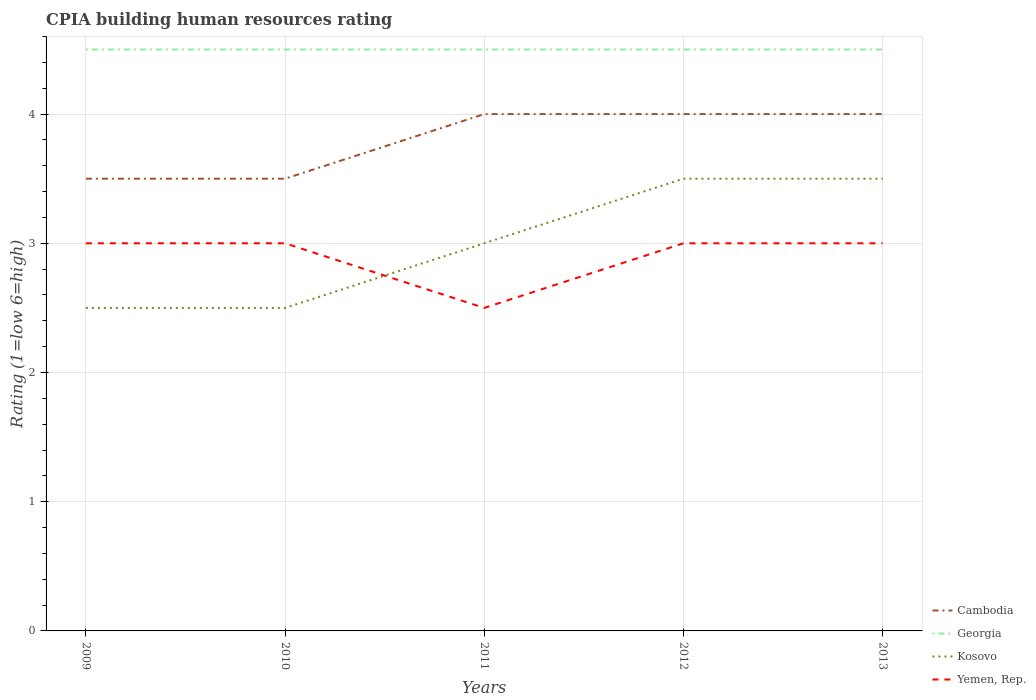Does the line corresponding to Cambodia intersect with the line corresponding to Georgia?
Make the answer very short. No. Is the number of lines equal to the number of legend labels?
Keep it short and to the point. Yes. In which year was the CPIA rating in Kosovo maximum?
Give a very brief answer. 2009. What is the difference between the highest and the second highest CPIA rating in Georgia?
Provide a succinct answer. 0. What is the difference between the highest and the lowest CPIA rating in Georgia?
Offer a very short reply. 0. Where does the legend appear in the graph?
Give a very brief answer. Bottom right. How many legend labels are there?
Your answer should be very brief. 4. How are the legend labels stacked?
Your answer should be very brief. Vertical. What is the title of the graph?
Your answer should be very brief. CPIA building human resources rating. Does "Belize" appear as one of the legend labels in the graph?
Your answer should be very brief. No. What is the Rating (1=low 6=high) in Cambodia in 2009?
Provide a succinct answer. 3.5. What is the Rating (1=low 6=high) of Kosovo in 2009?
Provide a succinct answer. 2.5. What is the Rating (1=low 6=high) in Yemen, Rep. in 2009?
Give a very brief answer. 3. What is the Rating (1=low 6=high) in Cambodia in 2010?
Keep it short and to the point. 3.5. What is the Rating (1=low 6=high) of Yemen, Rep. in 2010?
Your answer should be compact. 3. What is the Rating (1=low 6=high) of Georgia in 2011?
Offer a terse response. 4.5. What is the Rating (1=low 6=high) of Kosovo in 2012?
Your answer should be very brief. 3.5. What is the Rating (1=low 6=high) in Yemen, Rep. in 2012?
Offer a terse response. 3. What is the Rating (1=low 6=high) of Kosovo in 2013?
Make the answer very short. 3.5. Across all years, what is the minimum Rating (1=low 6=high) of Cambodia?
Make the answer very short. 3.5. Across all years, what is the minimum Rating (1=low 6=high) of Georgia?
Make the answer very short. 4.5. Across all years, what is the minimum Rating (1=low 6=high) of Yemen, Rep.?
Your answer should be compact. 2.5. What is the total Rating (1=low 6=high) in Cambodia in the graph?
Your answer should be compact. 19. What is the difference between the Rating (1=low 6=high) of Georgia in 2009 and that in 2010?
Your answer should be very brief. 0. What is the difference between the Rating (1=low 6=high) in Kosovo in 2009 and that in 2010?
Your response must be concise. 0. What is the difference between the Rating (1=low 6=high) of Cambodia in 2009 and that in 2011?
Your answer should be compact. -0.5. What is the difference between the Rating (1=low 6=high) of Georgia in 2009 and that in 2011?
Offer a very short reply. 0. What is the difference between the Rating (1=low 6=high) in Yemen, Rep. in 2009 and that in 2011?
Your answer should be compact. 0.5. What is the difference between the Rating (1=low 6=high) in Cambodia in 2009 and that in 2012?
Offer a very short reply. -0.5. What is the difference between the Rating (1=low 6=high) of Georgia in 2009 and that in 2012?
Offer a very short reply. 0. What is the difference between the Rating (1=low 6=high) of Yemen, Rep. in 2009 and that in 2013?
Provide a short and direct response. 0. What is the difference between the Rating (1=low 6=high) in Cambodia in 2010 and that in 2011?
Ensure brevity in your answer.  -0.5. What is the difference between the Rating (1=low 6=high) in Kosovo in 2010 and that in 2012?
Ensure brevity in your answer.  -1. What is the difference between the Rating (1=low 6=high) in Cambodia in 2010 and that in 2013?
Offer a terse response. -0.5. What is the difference between the Rating (1=low 6=high) in Georgia in 2010 and that in 2013?
Offer a very short reply. 0. What is the difference between the Rating (1=low 6=high) of Georgia in 2011 and that in 2012?
Ensure brevity in your answer.  0. What is the difference between the Rating (1=low 6=high) of Kosovo in 2011 and that in 2012?
Your response must be concise. -0.5. What is the difference between the Rating (1=low 6=high) in Yemen, Rep. in 2011 and that in 2012?
Keep it short and to the point. -0.5. What is the difference between the Rating (1=low 6=high) of Cambodia in 2012 and that in 2013?
Provide a short and direct response. 0. What is the difference between the Rating (1=low 6=high) of Georgia in 2012 and that in 2013?
Ensure brevity in your answer.  0. What is the difference between the Rating (1=low 6=high) of Yemen, Rep. in 2012 and that in 2013?
Keep it short and to the point. 0. What is the difference between the Rating (1=low 6=high) of Cambodia in 2009 and the Rating (1=low 6=high) of Yemen, Rep. in 2010?
Ensure brevity in your answer.  0.5. What is the difference between the Rating (1=low 6=high) of Georgia in 2009 and the Rating (1=low 6=high) of Kosovo in 2010?
Make the answer very short. 2. What is the difference between the Rating (1=low 6=high) in Georgia in 2009 and the Rating (1=low 6=high) in Yemen, Rep. in 2010?
Offer a terse response. 1.5. What is the difference between the Rating (1=low 6=high) of Kosovo in 2009 and the Rating (1=low 6=high) of Yemen, Rep. in 2010?
Keep it short and to the point. -0.5. What is the difference between the Rating (1=low 6=high) in Cambodia in 2009 and the Rating (1=low 6=high) in Georgia in 2011?
Provide a succinct answer. -1. What is the difference between the Rating (1=low 6=high) of Georgia in 2009 and the Rating (1=low 6=high) of Kosovo in 2011?
Ensure brevity in your answer.  1.5. What is the difference between the Rating (1=low 6=high) in Georgia in 2009 and the Rating (1=low 6=high) in Yemen, Rep. in 2011?
Your answer should be compact. 2. What is the difference between the Rating (1=low 6=high) of Cambodia in 2009 and the Rating (1=low 6=high) of Georgia in 2012?
Provide a short and direct response. -1. What is the difference between the Rating (1=low 6=high) in Cambodia in 2009 and the Rating (1=low 6=high) in Yemen, Rep. in 2012?
Keep it short and to the point. 0.5. What is the difference between the Rating (1=low 6=high) in Georgia in 2009 and the Rating (1=low 6=high) in Kosovo in 2012?
Your answer should be compact. 1. What is the difference between the Rating (1=low 6=high) of Georgia in 2009 and the Rating (1=low 6=high) of Yemen, Rep. in 2012?
Make the answer very short. 1.5. What is the difference between the Rating (1=low 6=high) in Kosovo in 2009 and the Rating (1=low 6=high) in Yemen, Rep. in 2012?
Ensure brevity in your answer.  -0.5. What is the difference between the Rating (1=low 6=high) of Cambodia in 2009 and the Rating (1=low 6=high) of Yemen, Rep. in 2013?
Provide a short and direct response. 0.5. What is the difference between the Rating (1=low 6=high) in Georgia in 2009 and the Rating (1=low 6=high) in Kosovo in 2013?
Offer a very short reply. 1. What is the difference between the Rating (1=low 6=high) of Cambodia in 2010 and the Rating (1=low 6=high) of Georgia in 2011?
Provide a succinct answer. -1. What is the difference between the Rating (1=low 6=high) of Cambodia in 2010 and the Rating (1=low 6=high) of Kosovo in 2011?
Your answer should be very brief. 0.5. What is the difference between the Rating (1=low 6=high) of Cambodia in 2010 and the Rating (1=low 6=high) of Yemen, Rep. in 2011?
Your answer should be compact. 1. What is the difference between the Rating (1=low 6=high) of Cambodia in 2010 and the Rating (1=low 6=high) of Kosovo in 2012?
Provide a succinct answer. 0. What is the difference between the Rating (1=low 6=high) of Cambodia in 2010 and the Rating (1=low 6=high) of Yemen, Rep. in 2013?
Offer a terse response. 0.5. What is the difference between the Rating (1=low 6=high) in Georgia in 2010 and the Rating (1=low 6=high) in Kosovo in 2013?
Provide a succinct answer. 1. What is the difference between the Rating (1=low 6=high) in Georgia in 2010 and the Rating (1=low 6=high) in Yemen, Rep. in 2013?
Your answer should be very brief. 1.5. What is the difference between the Rating (1=low 6=high) in Cambodia in 2011 and the Rating (1=low 6=high) in Kosovo in 2012?
Your response must be concise. 0.5. What is the difference between the Rating (1=low 6=high) of Cambodia in 2011 and the Rating (1=low 6=high) of Yemen, Rep. in 2012?
Your response must be concise. 1. What is the difference between the Rating (1=low 6=high) in Georgia in 2011 and the Rating (1=low 6=high) in Kosovo in 2012?
Give a very brief answer. 1. What is the difference between the Rating (1=low 6=high) of Georgia in 2011 and the Rating (1=low 6=high) of Yemen, Rep. in 2012?
Your response must be concise. 1.5. What is the difference between the Rating (1=low 6=high) in Cambodia in 2011 and the Rating (1=low 6=high) in Georgia in 2013?
Offer a very short reply. -0.5. What is the difference between the Rating (1=low 6=high) of Cambodia in 2011 and the Rating (1=low 6=high) of Kosovo in 2013?
Provide a short and direct response. 0.5. What is the difference between the Rating (1=low 6=high) of Cambodia in 2011 and the Rating (1=low 6=high) of Yemen, Rep. in 2013?
Your response must be concise. 1. What is the difference between the Rating (1=low 6=high) of Georgia in 2011 and the Rating (1=low 6=high) of Kosovo in 2013?
Your answer should be very brief. 1. What is the difference between the Rating (1=low 6=high) of Georgia in 2011 and the Rating (1=low 6=high) of Yemen, Rep. in 2013?
Ensure brevity in your answer.  1.5. What is the difference between the Rating (1=low 6=high) of Cambodia in 2012 and the Rating (1=low 6=high) of Yemen, Rep. in 2013?
Give a very brief answer. 1. What is the difference between the Rating (1=low 6=high) of Georgia in 2012 and the Rating (1=low 6=high) of Yemen, Rep. in 2013?
Your answer should be compact. 1.5. What is the average Rating (1=low 6=high) in Georgia per year?
Your answer should be very brief. 4.5. What is the average Rating (1=low 6=high) of Yemen, Rep. per year?
Provide a succinct answer. 2.9. In the year 2009, what is the difference between the Rating (1=low 6=high) in Cambodia and Rating (1=low 6=high) in Kosovo?
Ensure brevity in your answer.  1. In the year 2009, what is the difference between the Rating (1=low 6=high) in Georgia and Rating (1=low 6=high) in Kosovo?
Ensure brevity in your answer.  2. In the year 2009, what is the difference between the Rating (1=low 6=high) in Georgia and Rating (1=low 6=high) in Yemen, Rep.?
Provide a short and direct response. 1.5. In the year 2010, what is the difference between the Rating (1=low 6=high) of Cambodia and Rating (1=low 6=high) of Georgia?
Provide a succinct answer. -1. In the year 2010, what is the difference between the Rating (1=low 6=high) of Cambodia and Rating (1=low 6=high) of Kosovo?
Make the answer very short. 1. In the year 2010, what is the difference between the Rating (1=low 6=high) of Georgia and Rating (1=low 6=high) of Kosovo?
Provide a short and direct response. 2. In the year 2010, what is the difference between the Rating (1=low 6=high) in Kosovo and Rating (1=low 6=high) in Yemen, Rep.?
Offer a very short reply. -0.5. In the year 2011, what is the difference between the Rating (1=low 6=high) in Cambodia and Rating (1=low 6=high) in Georgia?
Offer a terse response. -0.5. In the year 2011, what is the difference between the Rating (1=low 6=high) of Cambodia and Rating (1=low 6=high) of Kosovo?
Keep it short and to the point. 1. In the year 2011, what is the difference between the Rating (1=low 6=high) of Cambodia and Rating (1=low 6=high) of Yemen, Rep.?
Offer a very short reply. 1.5. In the year 2011, what is the difference between the Rating (1=low 6=high) in Georgia and Rating (1=low 6=high) in Kosovo?
Give a very brief answer. 1.5. In the year 2011, what is the difference between the Rating (1=low 6=high) in Georgia and Rating (1=low 6=high) in Yemen, Rep.?
Provide a short and direct response. 2. In the year 2011, what is the difference between the Rating (1=low 6=high) of Kosovo and Rating (1=low 6=high) of Yemen, Rep.?
Keep it short and to the point. 0.5. In the year 2012, what is the difference between the Rating (1=low 6=high) in Cambodia and Rating (1=low 6=high) in Georgia?
Your answer should be compact. -0.5. In the year 2012, what is the difference between the Rating (1=low 6=high) of Cambodia and Rating (1=low 6=high) of Kosovo?
Your answer should be compact. 0.5. In the year 2013, what is the difference between the Rating (1=low 6=high) of Georgia and Rating (1=low 6=high) of Kosovo?
Provide a short and direct response. 1. In the year 2013, what is the difference between the Rating (1=low 6=high) of Georgia and Rating (1=low 6=high) of Yemen, Rep.?
Your response must be concise. 1.5. In the year 2013, what is the difference between the Rating (1=low 6=high) of Kosovo and Rating (1=low 6=high) of Yemen, Rep.?
Provide a short and direct response. 0.5. What is the ratio of the Rating (1=low 6=high) in Georgia in 2009 to that in 2010?
Your response must be concise. 1. What is the ratio of the Rating (1=low 6=high) of Kosovo in 2009 to that in 2010?
Make the answer very short. 1. What is the ratio of the Rating (1=low 6=high) of Cambodia in 2009 to that in 2011?
Provide a succinct answer. 0.88. What is the ratio of the Rating (1=low 6=high) in Yemen, Rep. in 2009 to that in 2011?
Your answer should be compact. 1.2. What is the ratio of the Rating (1=low 6=high) of Kosovo in 2009 to that in 2012?
Your answer should be very brief. 0.71. What is the ratio of the Rating (1=low 6=high) in Yemen, Rep. in 2009 to that in 2012?
Keep it short and to the point. 1. What is the ratio of the Rating (1=low 6=high) of Cambodia in 2010 to that in 2011?
Provide a succinct answer. 0.88. What is the ratio of the Rating (1=low 6=high) of Kosovo in 2010 to that in 2011?
Provide a succinct answer. 0.83. What is the ratio of the Rating (1=low 6=high) in Kosovo in 2010 to that in 2012?
Make the answer very short. 0.71. What is the ratio of the Rating (1=low 6=high) in Cambodia in 2010 to that in 2013?
Offer a very short reply. 0.88. What is the ratio of the Rating (1=low 6=high) in Georgia in 2010 to that in 2013?
Keep it short and to the point. 1. What is the ratio of the Rating (1=low 6=high) of Yemen, Rep. in 2010 to that in 2013?
Make the answer very short. 1. What is the ratio of the Rating (1=low 6=high) of Georgia in 2011 to that in 2012?
Make the answer very short. 1. What is the ratio of the Rating (1=low 6=high) of Yemen, Rep. in 2011 to that in 2012?
Give a very brief answer. 0.83. What is the ratio of the Rating (1=low 6=high) of Cambodia in 2011 to that in 2013?
Your answer should be compact. 1. What is the ratio of the Rating (1=low 6=high) of Kosovo in 2011 to that in 2013?
Offer a terse response. 0.86. What is the ratio of the Rating (1=low 6=high) in Yemen, Rep. in 2011 to that in 2013?
Provide a succinct answer. 0.83. What is the ratio of the Rating (1=low 6=high) in Kosovo in 2012 to that in 2013?
Make the answer very short. 1. What is the difference between the highest and the lowest Rating (1=low 6=high) in Cambodia?
Provide a succinct answer. 0.5. What is the difference between the highest and the lowest Rating (1=low 6=high) of Georgia?
Your response must be concise. 0. What is the difference between the highest and the lowest Rating (1=low 6=high) of Yemen, Rep.?
Provide a short and direct response. 0.5. 